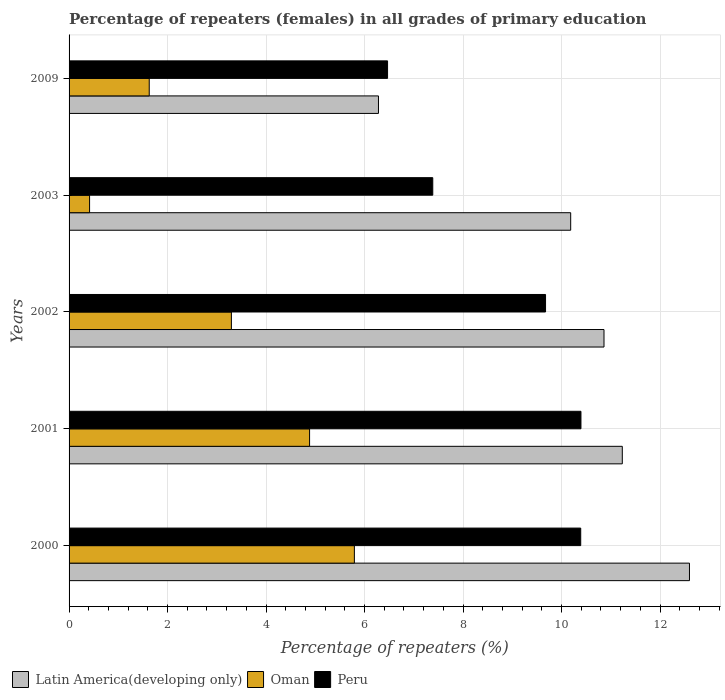How many different coloured bars are there?
Make the answer very short. 3. Are the number of bars per tick equal to the number of legend labels?
Provide a succinct answer. Yes. Are the number of bars on each tick of the Y-axis equal?
Your answer should be very brief. Yes. How many bars are there on the 2nd tick from the bottom?
Make the answer very short. 3. What is the percentage of repeaters (females) in Peru in 2009?
Provide a succinct answer. 6.47. Across all years, what is the maximum percentage of repeaters (females) in Peru?
Your answer should be very brief. 10.39. Across all years, what is the minimum percentage of repeaters (females) in Peru?
Ensure brevity in your answer.  6.47. In which year was the percentage of repeaters (females) in Peru minimum?
Your response must be concise. 2009. What is the total percentage of repeaters (females) in Latin America(developing only) in the graph?
Make the answer very short. 51.17. What is the difference between the percentage of repeaters (females) in Peru in 2003 and that in 2009?
Make the answer very short. 0.92. What is the difference between the percentage of repeaters (females) in Peru in 2000 and the percentage of repeaters (females) in Oman in 2002?
Your response must be concise. 7.09. What is the average percentage of repeaters (females) in Oman per year?
Make the answer very short. 3.2. In the year 2001, what is the difference between the percentage of repeaters (females) in Peru and percentage of repeaters (females) in Latin America(developing only)?
Your answer should be compact. -0.84. In how many years, is the percentage of repeaters (females) in Oman greater than 7.2 %?
Your answer should be compact. 0. What is the ratio of the percentage of repeaters (females) in Oman in 2000 to that in 2002?
Your response must be concise. 1.76. Is the difference between the percentage of repeaters (females) in Peru in 2002 and 2003 greater than the difference between the percentage of repeaters (females) in Latin America(developing only) in 2002 and 2003?
Offer a very short reply. Yes. What is the difference between the highest and the second highest percentage of repeaters (females) in Oman?
Make the answer very short. 0.91. What is the difference between the highest and the lowest percentage of repeaters (females) in Peru?
Offer a terse response. 3.93. In how many years, is the percentage of repeaters (females) in Oman greater than the average percentage of repeaters (females) in Oman taken over all years?
Offer a very short reply. 3. Is the sum of the percentage of repeaters (females) in Latin America(developing only) in 2002 and 2009 greater than the maximum percentage of repeaters (females) in Peru across all years?
Give a very brief answer. Yes. What does the 1st bar from the bottom in 2000 represents?
Offer a terse response. Latin America(developing only). Is it the case that in every year, the sum of the percentage of repeaters (females) in Oman and percentage of repeaters (females) in Latin America(developing only) is greater than the percentage of repeaters (females) in Peru?
Keep it short and to the point. Yes. Are all the bars in the graph horizontal?
Ensure brevity in your answer.  Yes. What is the difference between two consecutive major ticks on the X-axis?
Make the answer very short. 2. Are the values on the major ticks of X-axis written in scientific E-notation?
Your response must be concise. No. Does the graph contain any zero values?
Offer a terse response. No. Does the graph contain grids?
Provide a short and direct response. Yes. Where does the legend appear in the graph?
Keep it short and to the point. Bottom left. How are the legend labels stacked?
Give a very brief answer. Horizontal. What is the title of the graph?
Your response must be concise. Percentage of repeaters (females) in all grades of primary education. Does "Bhutan" appear as one of the legend labels in the graph?
Keep it short and to the point. No. What is the label or title of the X-axis?
Your response must be concise. Percentage of repeaters (%). What is the label or title of the Y-axis?
Ensure brevity in your answer.  Years. What is the Percentage of repeaters (%) in Latin America(developing only) in 2000?
Your answer should be very brief. 12.6. What is the Percentage of repeaters (%) in Oman in 2000?
Offer a terse response. 5.79. What is the Percentage of repeaters (%) in Peru in 2000?
Offer a very short reply. 10.39. What is the Percentage of repeaters (%) of Latin America(developing only) in 2001?
Provide a short and direct response. 11.23. What is the Percentage of repeaters (%) in Oman in 2001?
Keep it short and to the point. 4.88. What is the Percentage of repeaters (%) of Peru in 2001?
Keep it short and to the point. 10.39. What is the Percentage of repeaters (%) of Latin America(developing only) in 2002?
Offer a very short reply. 10.86. What is the Percentage of repeaters (%) of Oman in 2002?
Offer a terse response. 3.3. What is the Percentage of repeaters (%) of Peru in 2002?
Provide a short and direct response. 9.68. What is the Percentage of repeaters (%) of Latin America(developing only) in 2003?
Your answer should be very brief. 10.19. What is the Percentage of repeaters (%) of Oman in 2003?
Offer a terse response. 0.42. What is the Percentage of repeaters (%) in Peru in 2003?
Offer a terse response. 7.39. What is the Percentage of repeaters (%) in Latin America(developing only) in 2009?
Make the answer very short. 6.28. What is the Percentage of repeaters (%) in Oman in 2009?
Keep it short and to the point. 1.63. What is the Percentage of repeaters (%) in Peru in 2009?
Offer a terse response. 6.47. Across all years, what is the maximum Percentage of repeaters (%) in Latin America(developing only)?
Your answer should be very brief. 12.6. Across all years, what is the maximum Percentage of repeaters (%) of Oman?
Offer a very short reply. 5.79. Across all years, what is the maximum Percentage of repeaters (%) of Peru?
Provide a succinct answer. 10.39. Across all years, what is the minimum Percentage of repeaters (%) in Latin America(developing only)?
Offer a terse response. 6.28. Across all years, what is the minimum Percentage of repeaters (%) of Oman?
Keep it short and to the point. 0.42. Across all years, what is the minimum Percentage of repeaters (%) of Peru?
Your answer should be compact. 6.47. What is the total Percentage of repeaters (%) of Latin America(developing only) in the graph?
Keep it short and to the point. 51.17. What is the total Percentage of repeaters (%) in Oman in the graph?
Offer a terse response. 16.02. What is the total Percentage of repeaters (%) in Peru in the graph?
Your answer should be compact. 44.31. What is the difference between the Percentage of repeaters (%) in Latin America(developing only) in 2000 and that in 2001?
Give a very brief answer. 1.36. What is the difference between the Percentage of repeaters (%) of Oman in 2000 and that in 2001?
Your answer should be compact. 0.91. What is the difference between the Percentage of repeaters (%) in Peru in 2000 and that in 2001?
Provide a succinct answer. -0. What is the difference between the Percentage of repeaters (%) of Latin America(developing only) in 2000 and that in 2002?
Provide a succinct answer. 1.74. What is the difference between the Percentage of repeaters (%) of Oman in 2000 and that in 2002?
Your answer should be very brief. 2.5. What is the difference between the Percentage of repeaters (%) of Peru in 2000 and that in 2002?
Give a very brief answer. 0.71. What is the difference between the Percentage of repeaters (%) in Latin America(developing only) in 2000 and that in 2003?
Make the answer very short. 2.41. What is the difference between the Percentage of repeaters (%) in Oman in 2000 and that in 2003?
Provide a short and direct response. 5.38. What is the difference between the Percentage of repeaters (%) in Peru in 2000 and that in 2003?
Offer a very short reply. 3. What is the difference between the Percentage of repeaters (%) in Latin America(developing only) in 2000 and that in 2009?
Your answer should be very brief. 6.32. What is the difference between the Percentage of repeaters (%) in Oman in 2000 and that in 2009?
Provide a short and direct response. 4.17. What is the difference between the Percentage of repeaters (%) in Peru in 2000 and that in 2009?
Give a very brief answer. 3.92. What is the difference between the Percentage of repeaters (%) of Latin America(developing only) in 2001 and that in 2002?
Offer a terse response. 0.37. What is the difference between the Percentage of repeaters (%) of Oman in 2001 and that in 2002?
Provide a short and direct response. 1.59. What is the difference between the Percentage of repeaters (%) of Peru in 2001 and that in 2002?
Keep it short and to the point. 0.72. What is the difference between the Percentage of repeaters (%) in Latin America(developing only) in 2001 and that in 2003?
Make the answer very short. 1.05. What is the difference between the Percentage of repeaters (%) of Oman in 2001 and that in 2003?
Offer a terse response. 4.47. What is the difference between the Percentage of repeaters (%) of Peru in 2001 and that in 2003?
Your response must be concise. 3.01. What is the difference between the Percentage of repeaters (%) in Latin America(developing only) in 2001 and that in 2009?
Give a very brief answer. 4.95. What is the difference between the Percentage of repeaters (%) of Oman in 2001 and that in 2009?
Offer a very short reply. 3.26. What is the difference between the Percentage of repeaters (%) in Peru in 2001 and that in 2009?
Your answer should be very brief. 3.93. What is the difference between the Percentage of repeaters (%) in Latin America(developing only) in 2002 and that in 2003?
Provide a short and direct response. 0.68. What is the difference between the Percentage of repeaters (%) of Oman in 2002 and that in 2003?
Offer a very short reply. 2.88. What is the difference between the Percentage of repeaters (%) in Peru in 2002 and that in 2003?
Keep it short and to the point. 2.29. What is the difference between the Percentage of repeaters (%) of Latin America(developing only) in 2002 and that in 2009?
Keep it short and to the point. 4.58. What is the difference between the Percentage of repeaters (%) of Oman in 2002 and that in 2009?
Keep it short and to the point. 1.67. What is the difference between the Percentage of repeaters (%) in Peru in 2002 and that in 2009?
Offer a terse response. 3.21. What is the difference between the Percentage of repeaters (%) in Latin America(developing only) in 2003 and that in 2009?
Your response must be concise. 3.9. What is the difference between the Percentage of repeaters (%) in Oman in 2003 and that in 2009?
Keep it short and to the point. -1.21. What is the difference between the Percentage of repeaters (%) in Peru in 2003 and that in 2009?
Make the answer very short. 0.92. What is the difference between the Percentage of repeaters (%) of Latin America(developing only) in 2000 and the Percentage of repeaters (%) of Oman in 2001?
Offer a very short reply. 7.71. What is the difference between the Percentage of repeaters (%) in Latin America(developing only) in 2000 and the Percentage of repeaters (%) in Peru in 2001?
Make the answer very short. 2.2. What is the difference between the Percentage of repeaters (%) of Oman in 2000 and the Percentage of repeaters (%) of Peru in 2001?
Give a very brief answer. -4.6. What is the difference between the Percentage of repeaters (%) in Latin America(developing only) in 2000 and the Percentage of repeaters (%) in Oman in 2002?
Your answer should be very brief. 9.3. What is the difference between the Percentage of repeaters (%) of Latin America(developing only) in 2000 and the Percentage of repeaters (%) of Peru in 2002?
Provide a short and direct response. 2.92. What is the difference between the Percentage of repeaters (%) of Oman in 2000 and the Percentage of repeaters (%) of Peru in 2002?
Ensure brevity in your answer.  -3.88. What is the difference between the Percentage of repeaters (%) in Latin America(developing only) in 2000 and the Percentage of repeaters (%) in Oman in 2003?
Offer a very short reply. 12.18. What is the difference between the Percentage of repeaters (%) in Latin America(developing only) in 2000 and the Percentage of repeaters (%) in Peru in 2003?
Provide a succinct answer. 5.21. What is the difference between the Percentage of repeaters (%) in Oman in 2000 and the Percentage of repeaters (%) in Peru in 2003?
Your response must be concise. -1.59. What is the difference between the Percentage of repeaters (%) of Latin America(developing only) in 2000 and the Percentage of repeaters (%) of Oman in 2009?
Your answer should be compact. 10.97. What is the difference between the Percentage of repeaters (%) of Latin America(developing only) in 2000 and the Percentage of repeaters (%) of Peru in 2009?
Ensure brevity in your answer.  6.13. What is the difference between the Percentage of repeaters (%) of Oman in 2000 and the Percentage of repeaters (%) of Peru in 2009?
Your response must be concise. -0.67. What is the difference between the Percentage of repeaters (%) in Latin America(developing only) in 2001 and the Percentage of repeaters (%) in Oman in 2002?
Keep it short and to the point. 7.94. What is the difference between the Percentage of repeaters (%) of Latin America(developing only) in 2001 and the Percentage of repeaters (%) of Peru in 2002?
Give a very brief answer. 1.56. What is the difference between the Percentage of repeaters (%) of Oman in 2001 and the Percentage of repeaters (%) of Peru in 2002?
Offer a very short reply. -4.79. What is the difference between the Percentage of repeaters (%) in Latin America(developing only) in 2001 and the Percentage of repeaters (%) in Oman in 2003?
Give a very brief answer. 10.82. What is the difference between the Percentage of repeaters (%) of Latin America(developing only) in 2001 and the Percentage of repeaters (%) of Peru in 2003?
Your answer should be very brief. 3.85. What is the difference between the Percentage of repeaters (%) of Oman in 2001 and the Percentage of repeaters (%) of Peru in 2003?
Your answer should be very brief. -2.5. What is the difference between the Percentage of repeaters (%) of Latin America(developing only) in 2001 and the Percentage of repeaters (%) of Oman in 2009?
Give a very brief answer. 9.61. What is the difference between the Percentage of repeaters (%) in Latin America(developing only) in 2001 and the Percentage of repeaters (%) in Peru in 2009?
Your answer should be very brief. 4.77. What is the difference between the Percentage of repeaters (%) in Oman in 2001 and the Percentage of repeaters (%) in Peru in 2009?
Offer a terse response. -1.58. What is the difference between the Percentage of repeaters (%) of Latin America(developing only) in 2002 and the Percentage of repeaters (%) of Oman in 2003?
Give a very brief answer. 10.45. What is the difference between the Percentage of repeaters (%) of Latin America(developing only) in 2002 and the Percentage of repeaters (%) of Peru in 2003?
Provide a short and direct response. 3.48. What is the difference between the Percentage of repeaters (%) of Oman in 2002 and the Percentage of repeaters (%) of Peru in 2003?
Your response must be concise. -4.09. What is the difference between the Percentage of repeaters (%) in Latin America(developing only) in 2002 and the Percentage of repeaters (%) in Oman in 2009?
Provide a short and direct response. 9.23. What is the difference between the Percentage of repeaters (%) of Latin America(developing only) in 2002 and the Percentage of repeaters (%) of Peru in 2009?
Keep it short and to the point. 4.4. What is the difference between the Percentage of repeaters (%) of Oman in 2002 and the Percentage of repeaters (%) of Peru in 2009?
Provide a short and direct response. -3.17. What is the difference between the Percentage of repeaters (%) of Latin America(developing only) in 2003 and the Percentage of repeaters (%) of Oman in 2009?
Your answer should be compact. 8.56. What is the difference between the Percentage of repeaters (%) of Latin America(developing only) in 2003 and the Percentage of repeaters (%) of Peru in 2009?
Provide a succinct answer. 3.72. What is the difference between the Percentage of repeaters (%) in Oman in 2003 and the Percentage of repeaters (%) in Peru in 2009?
Give a very brief answer. -6.05. What is the average Percentage of repeaters (%) in Latin America(developing only) per year?
Your answer should be compact. 10.23. What is the average Percentage of repeaters (%) of Oman per year?
Provide a short and direct response. 3.2. What is the average Percentage of repeaters (%) of Peru per year?
Offer a terse response. 8.86. In the year 2000, what is the difference between the Percentage of repeaters (%) in Latin America(developing only) and Percentage of repeaters (%) in Oman?
Give a very brief answer. 6.8. In the year 2000, what is the difference between the Percentage of repeaters (%) in Latin America(developing only) and Percentage of repeaters (%) in Peru?
Your response must be concise. 2.21. In the year 2000, what is the difference between the Percentage of repeaters (%) in Oman and Percentage of repeaters (%) in Peru?
Your response must be concise. -4.6. In the year 2001, what is the difference between the Percentage of repeaters (%) in Latin America(developing only) and Percentage of repeaters (%) in Oman?
Offer a terse response. 6.35. In the year 2001, what is the difference between the Percentage of repeaters (%) in Latin America(developing only) and Percentage of repeaters (%) in Peru?
Offer a terse response. 0.84. In the year 2001, what is the difference between the Percentage of repeaters (%) of Oman and Percentage of repeaters (%) of Peru?
Your response must be concise. -5.51. In the year 2002, what is the difference between the Percentage of repeaters (%) in Latin America(developing only) and Percentage of repeaters (%) in Oman?
Your answer should be very brief. 7.57. In the year 2002, what is the difference between the Percentage of repeaters (%) in Latin America(developing only) and Percentage of repeaters (%) in Peru?
Your response must be concise. 1.19. In the year 2002, what is the difference between the Percentage of repeaters (%) in Oman and Percentage of repeaters (%) in Peru?
Offer a very short reply. -6.38. In the year 2003, what is the difference between the Percentage of repeaters (%) in Latin America(developing only) and Percentage of repeaters (%) in Oman?
Provide a short and direct response. 9.77. In the year 2003, what is the difference between the Percentage of repeaters (%) in Latin America(developing only) and Percentage of repeaters (%) in Peru?
Ensure brevity in your answer.  2.8. In the year 2003, what is the difference between the Percentage of repeaters (%) in Oman and Percentage of repeaters (%) in Peru?
Offer a terse response. -6.97. In the year 2009, what is the difference between the Percentage of repeaters (%) of Latin America(developing only) and Percentage of repeaters (%) of Oman?
Give a very brief answer. 4.66. In the year 2009, what is the difference between the Percentage of repeaters (%) of Latin America(developing only) and Percentage of repeaters (%) of Peru?
Make the answer very short. -0.18. In the year 2009, what is the difference between the Percentage of repeaters (%) of Oman and Percentage of repeaters (%) of Peru?
Offer a terse response. -4.84. What is the ratio of the Percentage of repeaters (%) in Latin America(developing only) in 2000 to that in 2001?
Ensure brevity in your answer.  1.12. What is the ratio of the Percentage of repeaters (%) in Oman in 2000 to that in 2001?
Give a very brief answer. 1.19. What is the ratio of the Percentage of repeaters (%) in Latin America(developing only) in 2000 to that in 2002?
Offer a terse response. 1.16. What is the ratio of the Percentage of repeaters (%) in Oman in 2000 to that in 2002?
Give a very brief answer. 1.76. What is the ratio of the Percentage of repeaters (%) of Peru in 2000 to that in 2002?
Keep it short and to the point. 1.07. What is the ratio of the Percentage of repeaters (%) in Latin America(developing only) in 2000 to that in 2003?
Ensure brevity in your answer.  1.24. What is the ratio of the Percentage of repeaters (%) in Oman in 2000 to that in 2003?
Ensure brevity in your answer.  13.91. What is the ratio of the Percentage of repeaters (%) in Peru in 2000 to that in 2003?
Give a very brief answer. 1.41. What is the ratio of the Percentage of repeaters (%) of Latin America(developing only) in 2000 to that in 2009?
Provide a succinct answer. 2.01. What is the ratio of the Percentage of repeaters (%) of Oman in 2000 to that in 2009?
Your answer should be very brief. 3.56. What is the ratio of the Percentage of repeaters (%) in Peru in 2000 to that in 2009?
Make the answer very short. 1.61. What is the ratio of the Percentage of repeaters (%) in Latin America(developing only) in 2001 to that in 2002?
Offer a terse response. 1.03. What is the ratio of the Percentage of repeaters (%) in Oman in 2001 to that in 2002?
Your response must be concise. 1.48. What is the ratio of the Percentage of repeaters (%) of Peru in 2001 to that in 2002?
Give a very brief answer. 1.07. What is the ratio of the Percentage of repeaters (%) of Latin America(developing only) in 2001 to that in 2003?
Ensure brevity in your answer.  1.1. What is the ratio of the Percentage of repeaters (%) in Oman in 2001 to that in 2003?
Provide a succinct answer. 11.73. What is the ratio of the Percentage of repeaters (%) in Peru in 2001 to that in 2003?
Give a very brief answer. 1.41. What is the ratio of the Percentage of repeaters (%) of Latin America(developing only) in 2001 to that in 2009?
Ensure brevity in your answer.  1.79. What is the ratio of the Percentage of repeaters (%) of Oman in 2001 to that in 2009?
Offer a very short reply. 3. What is the ratio of the Percentage of repeaters (%) in Peru in 2001 to that in 2009?
Ensure brevity in your answer.  1.61. What is the ratio of the Percentage of repeaters (%) of Latin America(developing only) in 2002 to that in 2003?
Your answer should be very brief. 1.07. What is the ratio of the Percentage of repeaters (%) in Oman in 2002 to that in 2003?
Provide a short and direct response. 7.92. What is the ratio of the Percentage of repeaters (%) of Peru in 2002 to that in 2003?
Your answer should be very brief. 1.31. What is the ratio of the Percentage of repeaters (%) in Latin America(developing only) in 2002 to that in 2009?
Give a very brief answer. 1.73. What is the ratio of the Percentage of repeaters (%) in Oman in 2002 to that in 2009?
Offer a very short reply. 2.02. What is the ratio of the Percentage of repeaters (%) in Peru in 2002 to that in 2009?
Provide a short and direct response. 1.5. What is the ratio of the Percentage of repeaters (%) in Latin America(developing only) in 2003 to that in 2009?
Keep it short and to the point. 1.62. What is the ratio of the Percentage of repeaters (%) in Oman in 2003 to that in 2009?
Offer a very short reply. 0.26. What is the ratio of the Percentage of repeaters (%) of Peru in 2003 to that in 2009?
Offer a very short reply. 1.14. What is the difference between the highest and the second highest Percentage of repeaters (%) in Latin America(developing only)?
Your answer should be compact. 1.36. What is the difference between the highest and the second highest Percentage of repeaters (%) in Oman?
Provide a succinct answer. 0.91. What is the difference between the highest and the second highest Percentage of repeaters (%) in Peru?
Give a very brief answer. 0. What is the difference between the highest and the lowest Percentage of repeaters (%) of Latin America(developing only)?
Provide a short and direct response. 6.32. What is the difference between the highest and the lowest Percentage of repeaters (%) of Oman?
Your response must be concise. 5.38. What is the difference between the highest and the lowest Percentage of repeaters (%) in Peru?
Your response must be concise. 3.93. 